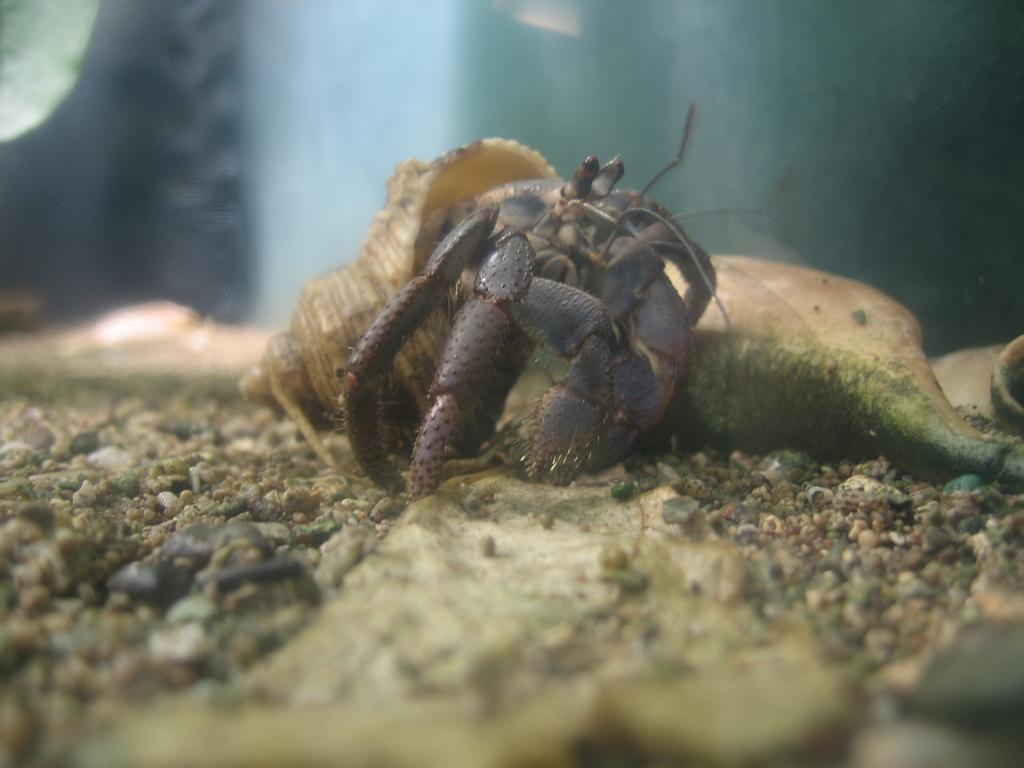What type of animal is in the image? The type of animal cannot be determined from the provided facts. What can be found among the small stones in the image? There are small stones in the image. What is the texture of the ground in the image? The ground in the image is covered with sand. What type of fuel is being used by the owl in the image? There is no owl present in the image, and therefore no fuel can be associated with it. What is the thing that the owl is holding in the image? There is no owl or thing present in the image. 